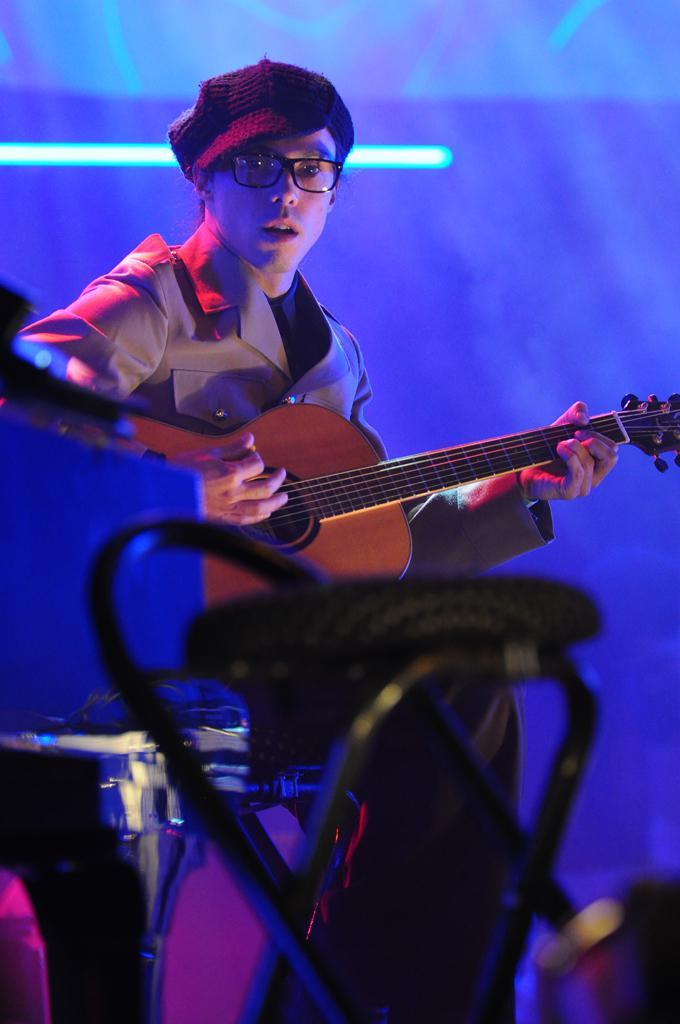What is the main subject of the image? The main subject of the image is a man. What is the man doing in the image? The man is playing a guitar in the image. What is the man sitting on in the image? The man is sitting on a chair in the image. What type of disgust can be seen on the man's face while playing the guitar in the image? There is no indication of disgust on the man's face in the image; he appears to be focused on playing the guitar. 